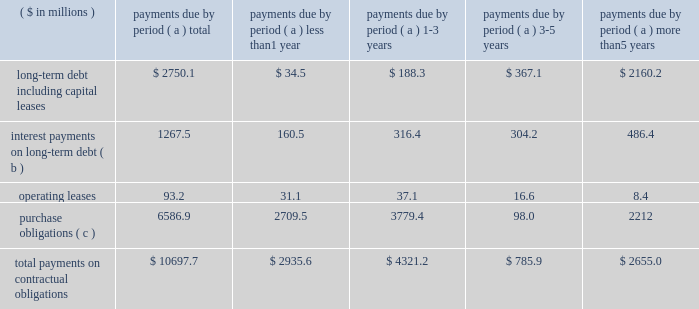Page 27 of 100 other liquidity items cash payments required for long-term debt maturities , rental payments under noncancellable operating leases , purchase obligations and other commitments in effect at december 31 , 2010 , are summarized in the table: .
Total payments on contractual obligations $ 10697.7 $ 2935.6 $ 4321.2 $ 785.9 $ 2655.0 ( a ) amounts reported in local currencies have been translated at the year-end 2010 exchange rates .
( b ) for variable rate facilities , amounts are based on interest rates in effect at year end and do not contemplate the effects of hedging instruments .
( c ) the company 2019s purchase obligations include contracted amounts for aluminum , steel and other direct materials .
Also included are commitments for purchases of natural gas and electricity , aerospace and technologies contracts and other less significant items .
In cases where variable prices and/or usage are involved , management 2019s best estimates have been used .
Depending on the circumstances , early termination of the contracts may or may not result in penalties and , therefore , actual payments could vary significantly .
The table above does not include $ 60.1 million of uncertain tax positions , the timing of which is uncertain .
Contributions to the company 2019s defined benefit pension plans , not including the unfunded german plans , are expected to be in the range of $ 30 million in 2011 .
This estimate may change based on changes in the pension protection act and actual plan asset performance , among other factors .
Benefit payments related to these plans are expected to be $ 71.4 million , $ 74.0 million , $ 77.1 million , $ 80.3 million and $ 84.9 million for the years ending december 31 , 2011 through 2015 , respectively , and a total of $ 483.1 million for the years 2016 through 2020 .
Payments to participants in the unfunded german plans are expected to be between $ 21.8 million ( 20ac16.5 million ) to $ 23.2 million ( 20ac17.5 million ) in each of the years 2011 through 2015 and a total of $ 102.7 million ( 20ac77.5 million ) for the years 2016 through 2020 .
For the u.s .
Pension plans in 2011 , we changed our return on asset assumption to 8.00 percent ( from 8.25 percent in 2010 ) and our discount rate assumption to an average of 5.55 percent ( from 6.00 percent in 2010 ) .
Based on the changes in assumptions , pension expense in 2011 is anticipated to be relatively flat compared to 2010 .
A reduction of the expected return on pension assets assumption by a quarter of a percentage point would result in an estimated $ 2.9 million increase in the 2011 global pension expense , while a quarter of a percentage point reduction in the discount rate applied to the pension liability would result in an estimated $ 3.5 million of additional pension expense in 2011 .
Additional information regarding the company 2019s pension plans is provided in note 14 accompanying the consolidated financial statements within item 8 of this report .
Annual cash dividends paid on common stock were 20 cents per share in 2010 , 2009 and 2008 .
Total dividends paid were $ 35.8 million in 2010 , $ 37.4 million in 2009 and $ 37.5 million in 2008 .
On january 26 , 2011 , the company 2019s board of directors approved an increase in the quarterly dividends to 7 cents per share .
Share repurchases our share repurchases , net of issuances , totaled $ 506.7 million in 2010 , $ 5.1 million in 2009 and $ 299.6 million in 2008 .
On november 2 , 2010 , we acquired 2775408 shares of our publicly held common stock in a private transaction for $ 88.8 million .
On february 17 , 2010 , we entered into an accelerated share repurchase agreement to buy $ 125.0 million of our common shares using cash on hand and available borrowings .
We advanced the $ 125.0 million on february 22 , 2010 , and received 4323598 shares , which represented 90 percent of the total shares as calculated using the previous day 2019s closing price .
The agreement was settled on may 20 , 2010 , and the company received an additional 398206 shares .
Net repurchases in 2008 included a $ 31 million settlement on january 7 , 2008 , of a forward contract entered into in december 2007 for the repurchase of 1350000 shares .
From january 1 through february 24 , 2011 , ball repurchased an additional $ 143.3 million of its common stock. .
Was was the average cost per share of the 2008 settlement of the 2007 forward repo contract? 
Computations: ((31 * 1000000) / 1350000)
Answer: 22.96296. 